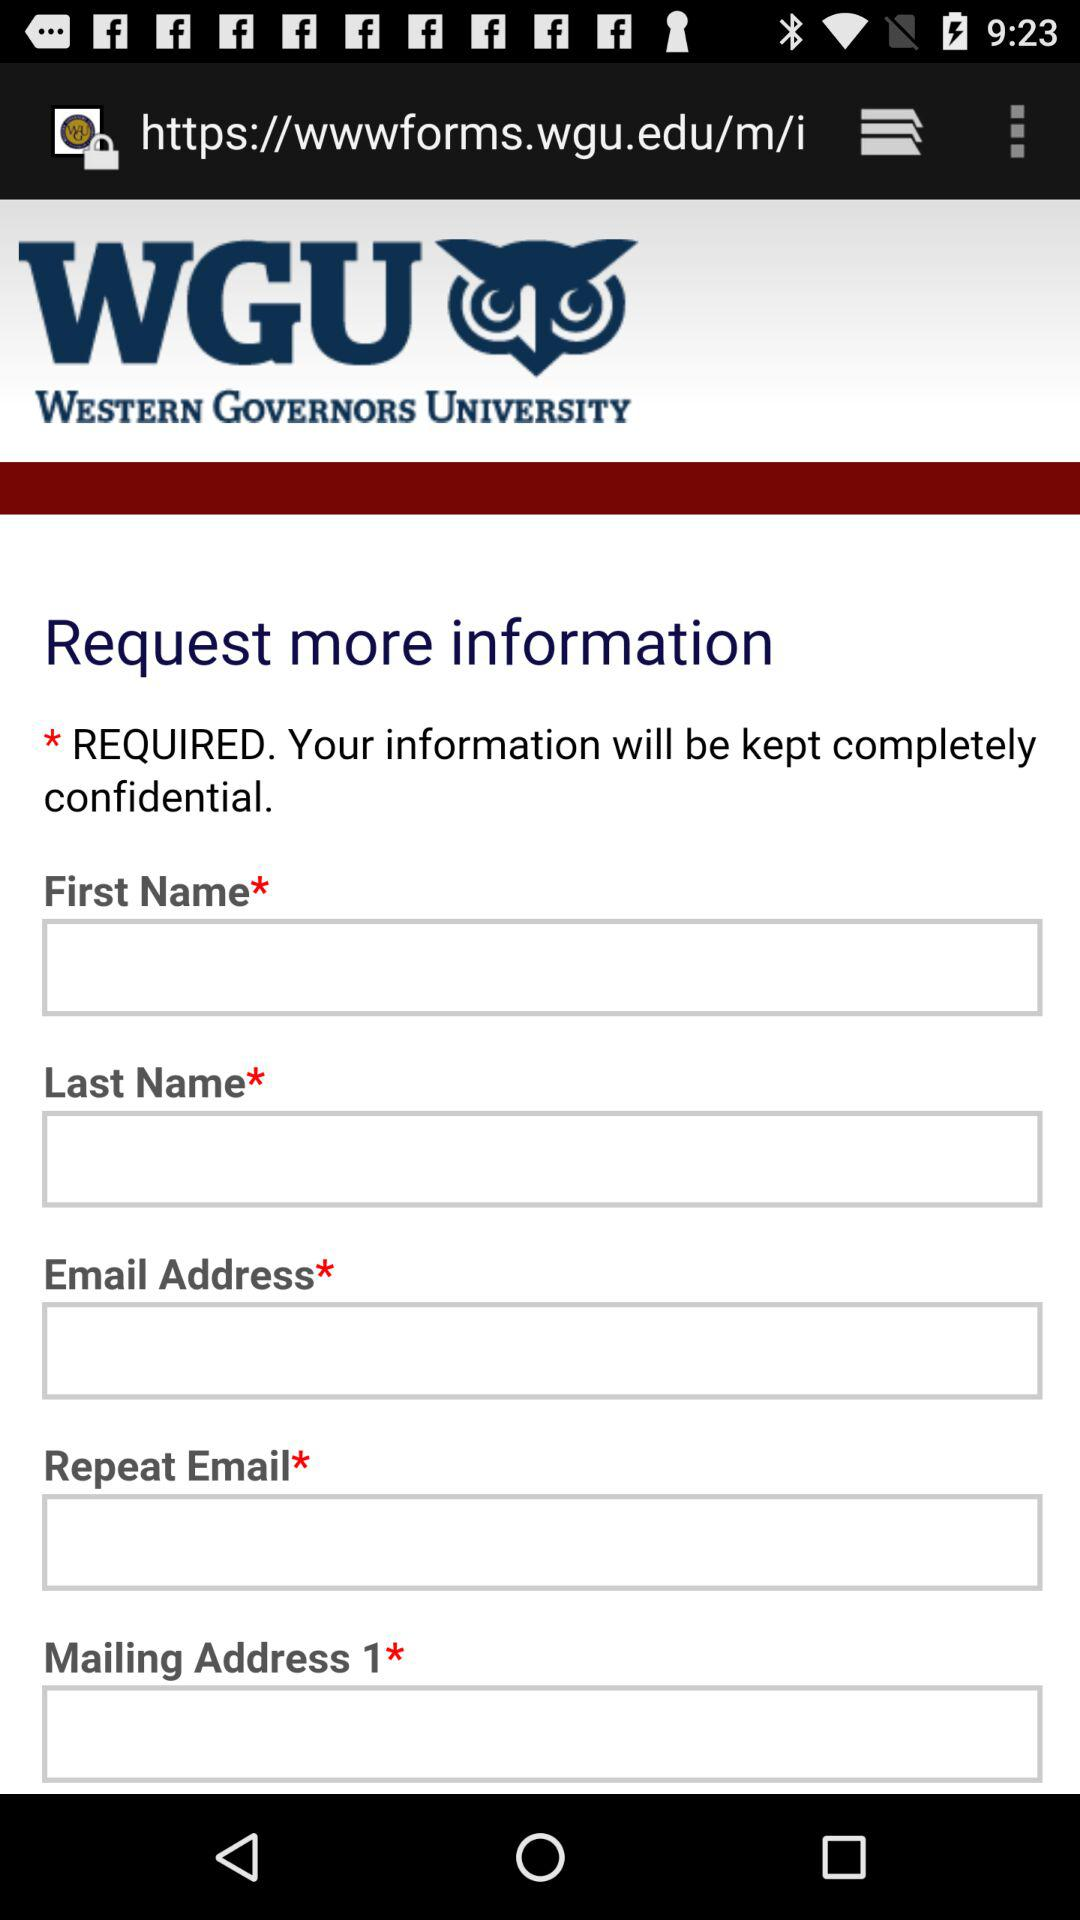How many text inputs are required?
Answer the question using a single word or phrase. 5 